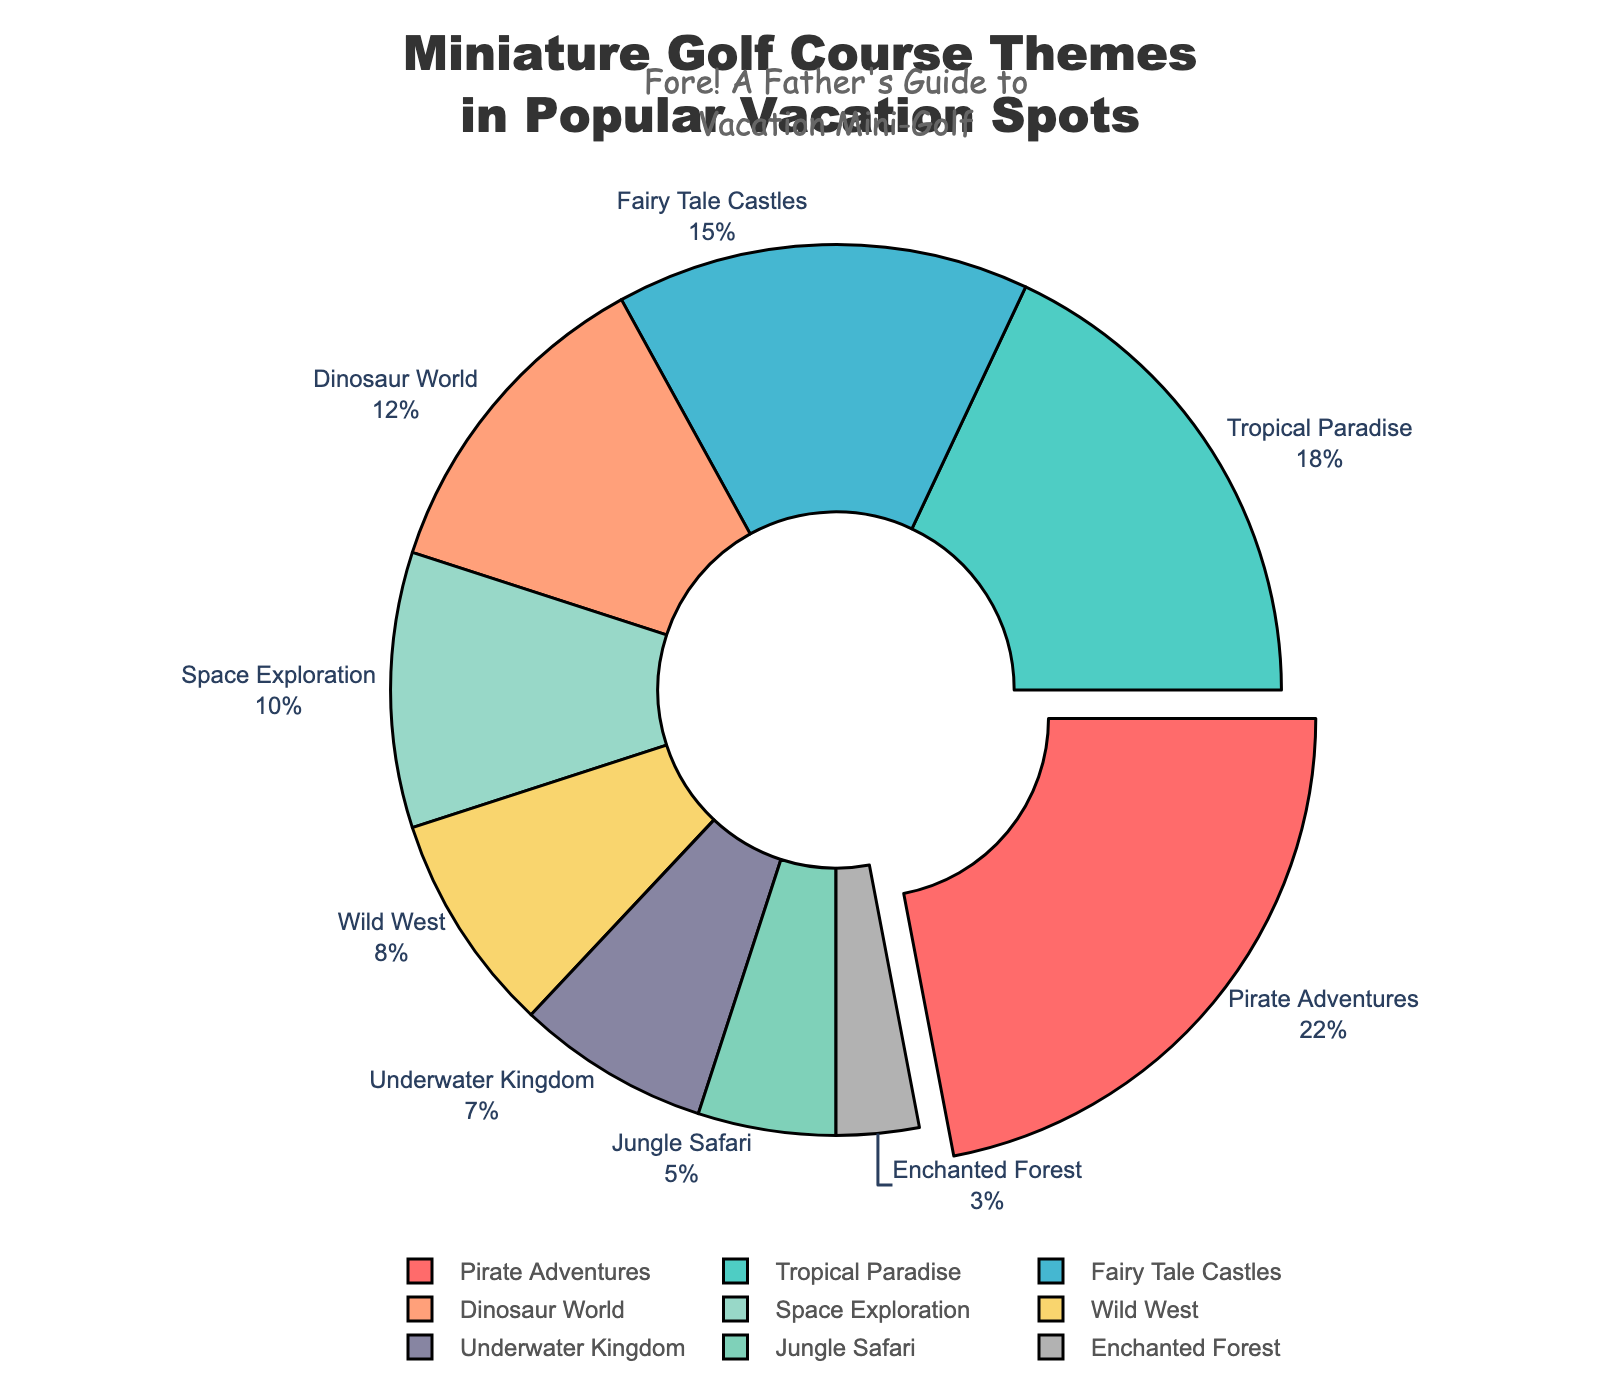what theme has the highest percentage? The slice with the largest percentage is labeled and pulled slightly away from the center, which shows that it’s 'Pirate Adventures' with its percentage written outside.
Answer: Pirate Adventures Which two themes combined have a percentage equal to that of 'Pirate Adventures'? 'Pirate Adventures' has 22%. To find two themes that sum up to this, look for themes with combined values equal to 22%. 'Wild West' (8%) and 'Space Exploration' (10%) make 18%, but adding 'Enchanted Forest' (3%) will make 21%. Therefore, 'Dinosaur World' (12%) and 'Fairy Tale Castles' (15%) make 27%.
Answer: Wild West and Space Exploration plus Enchanted Forest What's the difference in percentage between 'Tropical Paradise' and 'Jungle Safari'? 'Tropical Paradise' is 18% and 'Jungle Safari' is 5%. Subtracting 5 from 18 gives the difference.
Answer: 13% How many themes have a smaller percentage than 'Underwater Kingdom'? 'Underwater Kingdom' is 7%. Check each theme’s percentage to see which ones are smaller: 'Jungle Safari' (5%) and 'Enchanted Forest' (3%) are the only ones smaller.
Answer: 2 Which theme has the coolest color scheme (cool colors such as blue, green)? Look for the cooler colors in the pie chart. Themes with cool colors are 'Underwater Kingdom' (Blue) and 'Jungle Safari' (Green). Compare to the data for confirmation.
Answer: Underwater Kingdom Which theme would you infer to be the least popular based on the pie chart? The smallest slice in the pie chart is labeled 'Enchanted Forest’, indicating that it has the lowest percentage at 3%.
Answer: Enchanted Forest What's the combined percentage of all themes that focus on animals or nature? Themes related to animals or nature are 'Tropical Paradise' (18%), 'Jungle Safari' (5%), and 'Underwater Kingdom' (7%). Summing these gives 18 + 5 + 7.
Answer: 30% What percentage is represented by themes involving historical or mythical adventures? 'Pirate Adventures' (22%), 'Wild West' (8%), and 'Fairy Tale Castles' (15%). Summing these gives 22 + 8 + 15.
Answer: 45% What's the collective percentage for themes that do not exceed 10% individually? 'Dinosaur World' (12%), 'Space Exploration' (10%), 'Wild West' (8%), 'Underwater Kingdom' (7%), 'Jungle Safari' (5%), 'Enchanted Forest' (3%). Only 'Space Exploration', 'Wild West', 'Underwater Kingdom', 'Jungle Safari', and 'Enchanted Forest' fit, summing gives 10+8+7+5+3.
Answer: 33% What's the percentage sum of the three most popular themes? The most popular themes are 'Pirate Adventures' (22%), 'Tropical Paradise' (18%), and 'Fairy Tale Castles' (15%). Adding these together gives 22 + 18 + 15.
Answer: 55% 